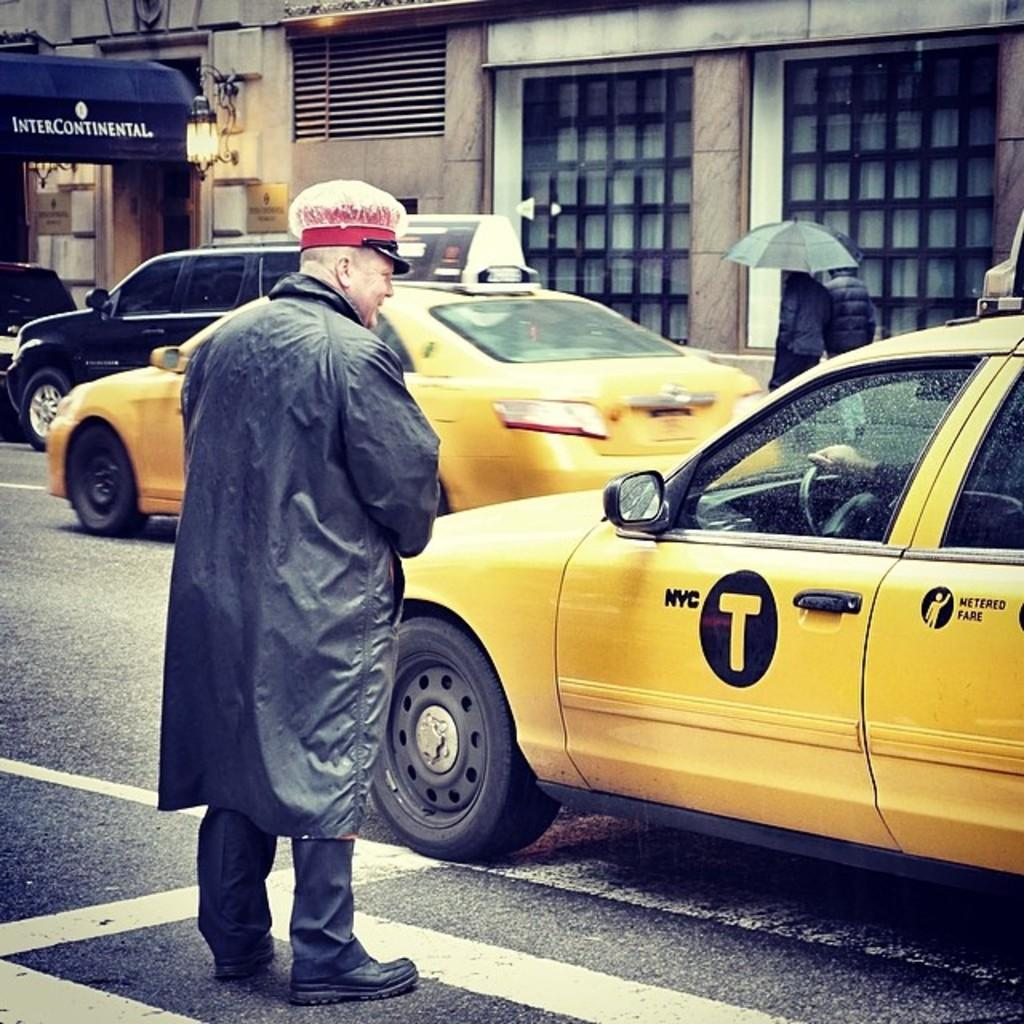<image>
Give a short and clear explanation of the subsequent image. A man with ared hat in a raincoat stands next to a NYC Taxi sitting at a crosswalk. 